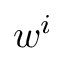<formula> <loc_0><loc_0><loc_500><loc_500>w ^ { i }</formula> 